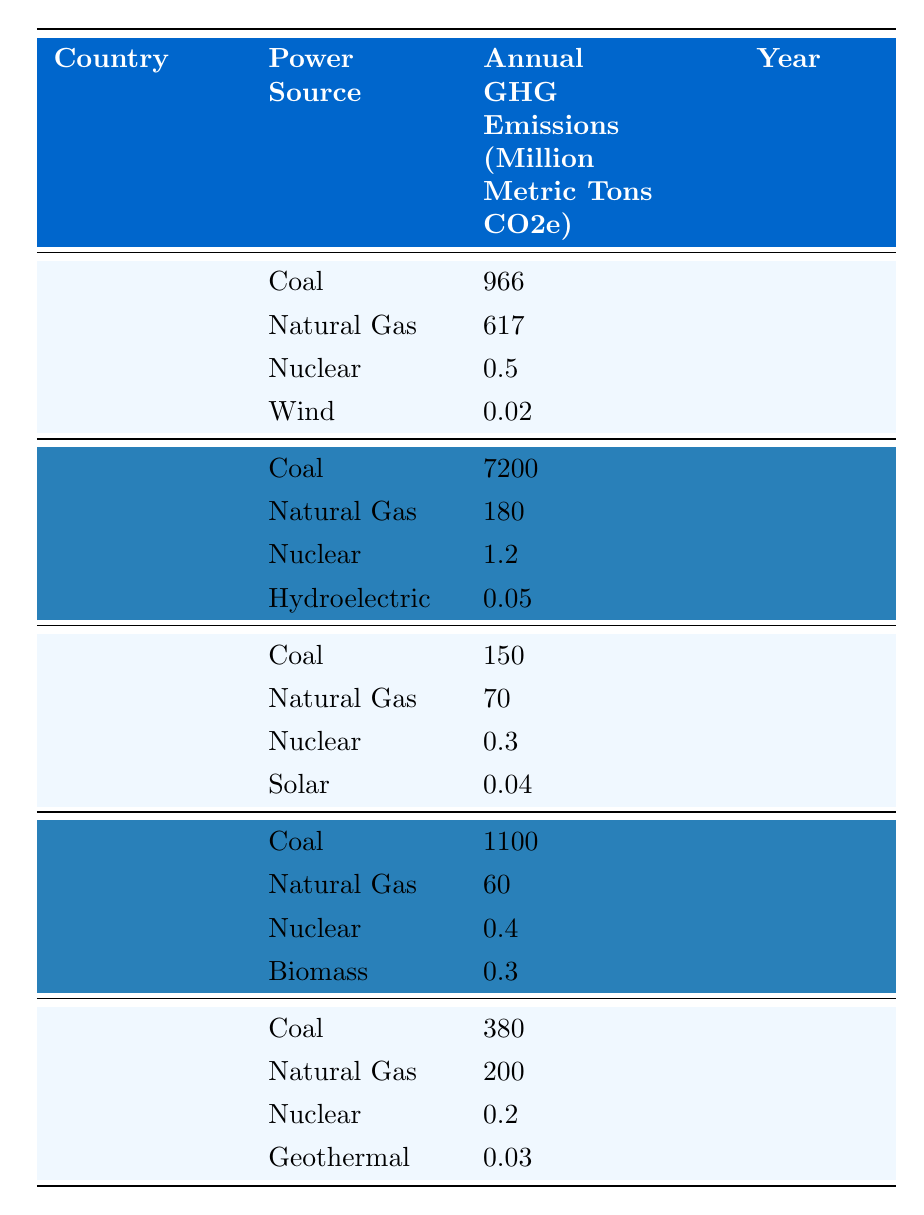What is the GHG emission from coal in the United States? In the table, under the United States and coal, the annual GHG emissions are listed as 966 million metric tons CO2e.
Answer: 966 million metric tons CO2e Which power source in China produced the highest GHG emissions? In the table, China has coal with 7200 million metric tons CO2e, which is higher than any other power source listed for China.
Answer: Coal What are the total GHG emissions from all power sources in Germany? For Germany, the emissions from coal (150), natural gas (70), nuclear (0.3), and solar (0.04) should be summed: 150 + 70 + 0.3 + 0.04 = 220.34 million metric tons CO2e.
Answer: 220.34 million metric tons CO2e Is the GHG emission from nuclear power in Japan higher than that from geothermal power? In the table, Japan's nuclear emission is 0.2 million metric tons CO2e, and geothermal is 0.03 million metric tons CO2e. Since 0.2 > 0.03, the statement is true.
Answer: Yes What country has the lowest annual GHG emission from wind power? The only data for wind power is from the United States, which has 0.02 million metric tons CO2e; thus, it is the lowest since no other country listed emissions for wind power.
Answer: United States What is the average GHG emissions from natural gas across all countries listed? The emissions data for natural gas are: United States (617), China (180), Germany (70), India (60), and Japan (200). The average is calculated as (617 + 180 + 70 + 60 + 200) / 5 = 225.4 million metric tons CO2e.
Answer: 225.4 million metric tons CO2e Which country emits more GHG from coal: China or India? Comparing coal emissions, China has 7200 million metric tons CO2e and India has 1100 million metric tons CO2e. Since 7200 > 1100, China emits more.
Answer: China If we consider all countries, which power source is associated with the least GHG emissions? Reviewing the table, wind (0.02), nuclear (0.2), and geothermal (0.03) emissions appear to be the lowest. Comparing these values, wind has the least at 0.02 million metric tons CO2e.
Answer: Wind What percentage of Japan's total GHG emissions is attributed to coal? In Japan, coal emissions are 380 million metric tons CO2e, and total emissions from all sources are 380 + 200 + 0.2 + 0.03 = 580.23 million metric tons CO2e. The percentage is (380 / 580.23) * 100 ≈ 65.5%.
Answer: Approximately 65.5% Are the GHG emissions from biomass in India higher than those from hydroelectric power in China? In India, biomass is listed as 0.3 million metric tons CO2e, and in China, hydroelectric is at 0.05 million metric tons CO2e. Since 0.3 > 0.05, the statement is true.
Answer: Yes 